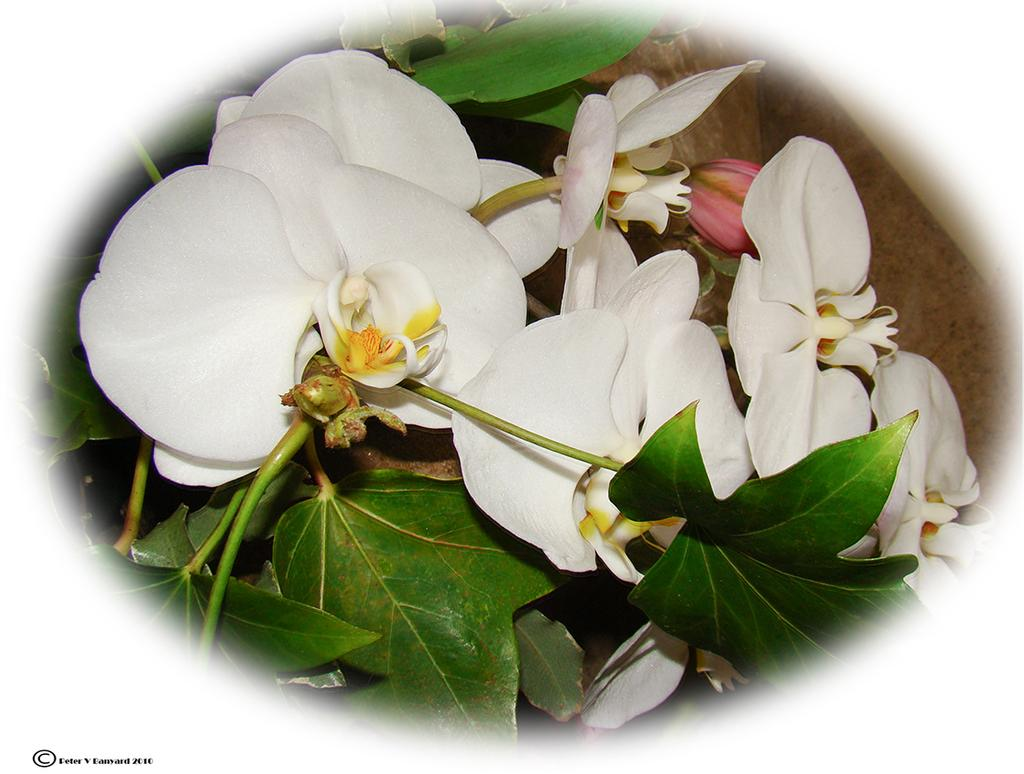What type of plant life is visible in the image? There are flowers, stems, and leaves in the image. Can you describe the structure of the plants in the image? The plants have stems and leaves, and some of them have flowers. Is there any text or marking visible in the image? Yes, there is a watermark on the left side, bottom of the image. What type of door can be seen in the image? There is no door present in the image; it features flowers, stems, leaves, and a watermark. 